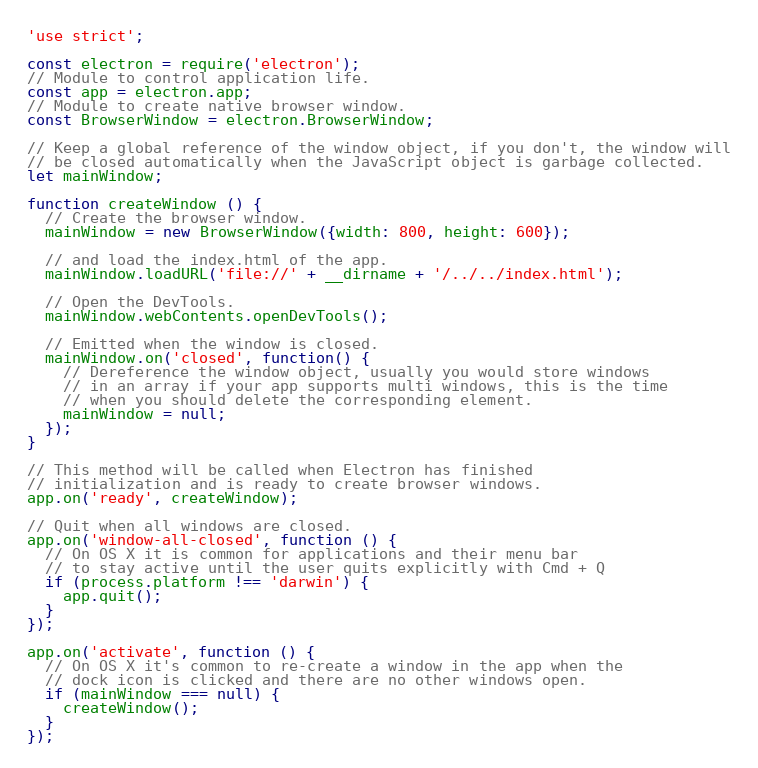Convert code to text. <code><loc_0><loc_0><loc_500><loc_500><_JavaScript_>'use strict';

const electron = require('electron');
// Module to control application life.
const app = electron.app;
// Module to create native browser window.
const BrowserWindow = electron.BrowserWindow;

// Keep a global reference of the window object, if you don't, the window will
// be closed automatically when the JavaScript object is garbage collected.
let mainWindow;

function createWindow () {
  // Create the browser window.
  mainWindow = new BrowserWindow({width: 800, height: 600});

  // and load the index.html of the app.
  mainWindow.loadURL('file://' + __dirname + '/../../index.html');

  // Open the DevTools.
  mainWindow.webContents.openDevTools();

  // Emitted when the window is closed.
  mainWindow.on('closed', function() {
    // Dereference the window object, usually you would store windows
    // in an array if your app supports multi windows, this is the time
    // when you should delete the corresponding element.
    mainWindow = null;
  });
}

// This method will be called when Electron has finished
// initialization and is ready to create browser windows.
app.on('ready', createWindow);

// Quit when all windows are closed.
app.on('window-all-closed', function () {
  // On OS X it is common for applications and their menu bar
  // to stay active until the user quits explicitly with Cmd + Q
  if (process.platform !== 'darwin') {
    app.quit();
  }
});

app.on('activate', function () {
  // On OS X it's common to re-create a window in the app when the
  // dock icon is clicked and there are no other windows open.
  if (mainWindow === null) {
    createWindow();
  }
});</code> 